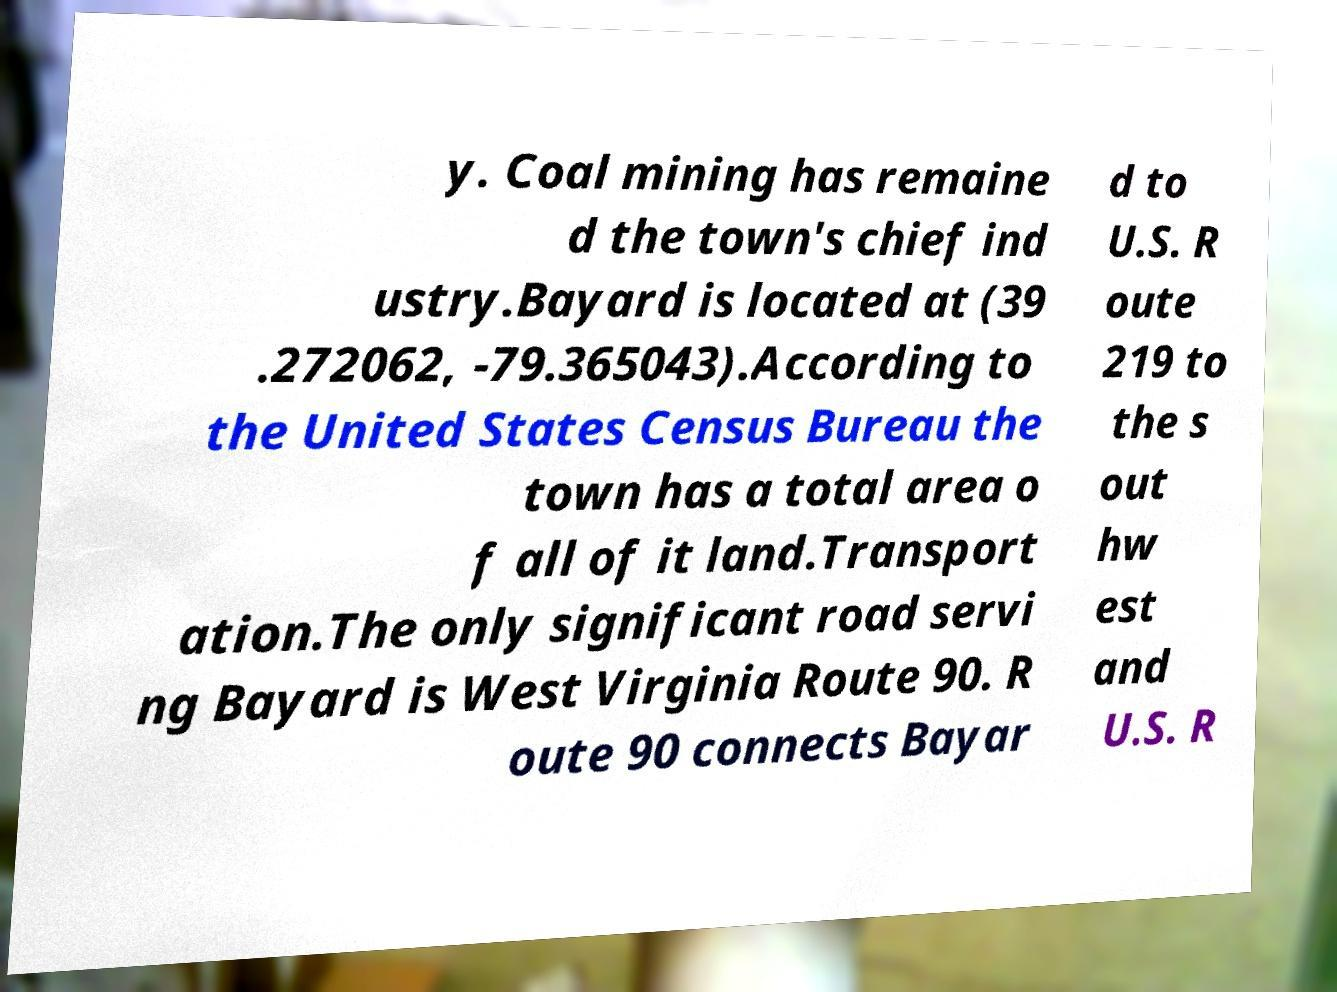Please identify and transcribe the text found in this image. y. Coal mining has remaine d the town's chief ind ustry.Bayard is located at (39 .272062, -79.365043).According to the United States Census Bureau the town has a total area o f all of it land.Transport ation.The only significant road servi ng Bayard is West Virginia Route 90. R oute 90 connects Bayar d to U.S. R oute 219 to the s out hw est and U.S. R 